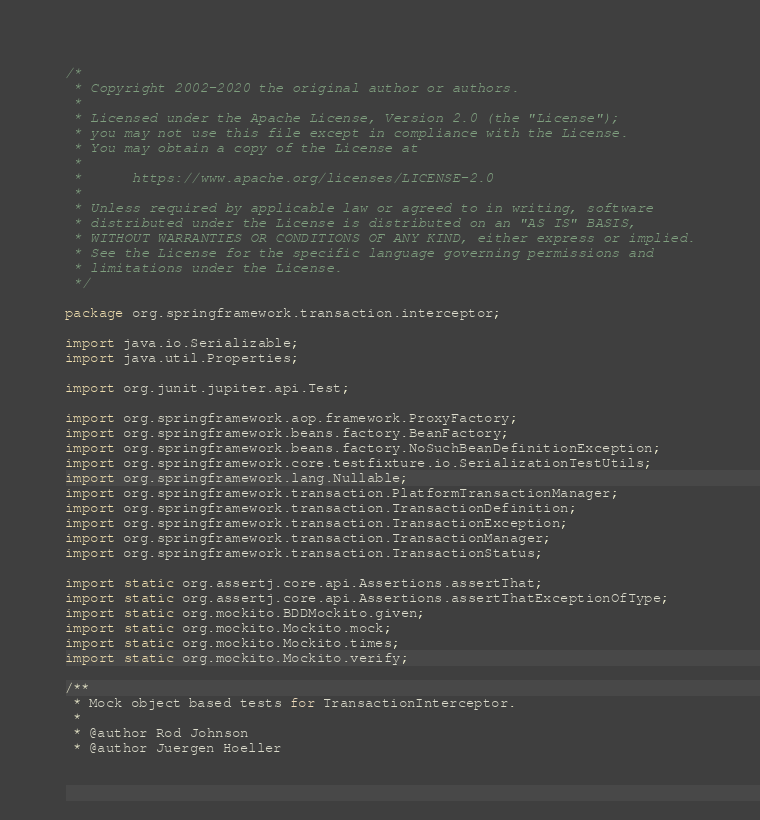Convert code to text. <code><loc_0><loc_0><loc_500><loc_500><_Java_>/*
 * Copyright 2002-2020 the original author or authors.
 *
 * Licensed under the Apache License, Version 2.0 (the "License");
 * you may not use this file except in compliance with the License.
 * You may obtain a copy of the License at
 *
 *      https://www.apache.org/licenses/LICENSE-2.0
 *
 * Unless required by applicable law or agreed to in writing, software
 * distributed under the License is distributed on an "AS IS" BASIS,
 * WITHOUT WARRANTIES OR CONDITIONS OF ANY KIND, either express or implied.
 * See the License for the specific language governing permissions and
 * limitations under the License.
 */

package org.springframework.transaction.interceptor;

import java.io.Serializable;
import java.util.Properties;

import org.junit.jupiter.api.Test;

import org.springframework.aop.framework.ProxyFactory;
import org.springframework.beans.factory.BeanFactory;
import org.springframework.beans.factory.NoSuchBeanDefinitionException;
import org.springframework.core.testfixture.io.SerializationTestUtils;
import org.springframework.lang.Nullable;
import org.springframework.transaction.PlatformTransactionManager;
import org.springframework.transaction.TransactionDefinition;
import org.springframework.transaction.TransactionException;
import org.springframework.transaction.TransactionManager;
import org.springframework.transaction.TransactionStatus;

import static org.assertj.core.api.Assertions.assertThat;
import static org.assertj.core.api.Assertions.assertThatExceptionOfType;
import static org.mockito.BDDMockito.given;
import static org.mockito.Mockito.mock;
import static org.mockito.Mockito.times;
import static org.mockito.Mockito.verify;

/**
 * Mock object based tests for TransactionInterceptor.
 *
 * @author Rod Johnson
 * @author Juergen Hoeller</code> 